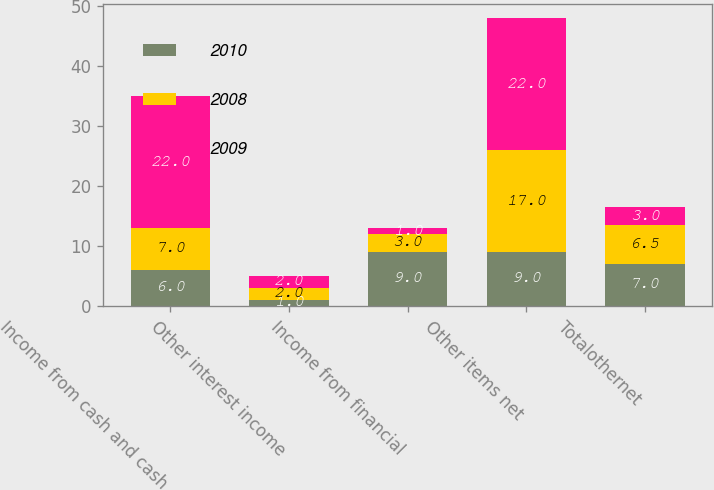<chart> <loc_0><loc_0><loc_500><loc_500><stacked_bar_chart><ecel><fcel>Income from cash and cash<fcel>Other interest income<fcel>Income from financial<fcel>Other items net<fcel>Totalothernet<nl><fcel>2010<fcel>6<fcel>1<fcel>9<fcel>9<fcel>7<nl><fcel>2008<fcel>7<fcel>2<fcel>3<fcel>17<fcel>6.5<nl><fcel>2009<fcel>22<fcel>2<fcel>1<fcel>22<fcel>3<nl></chart> 